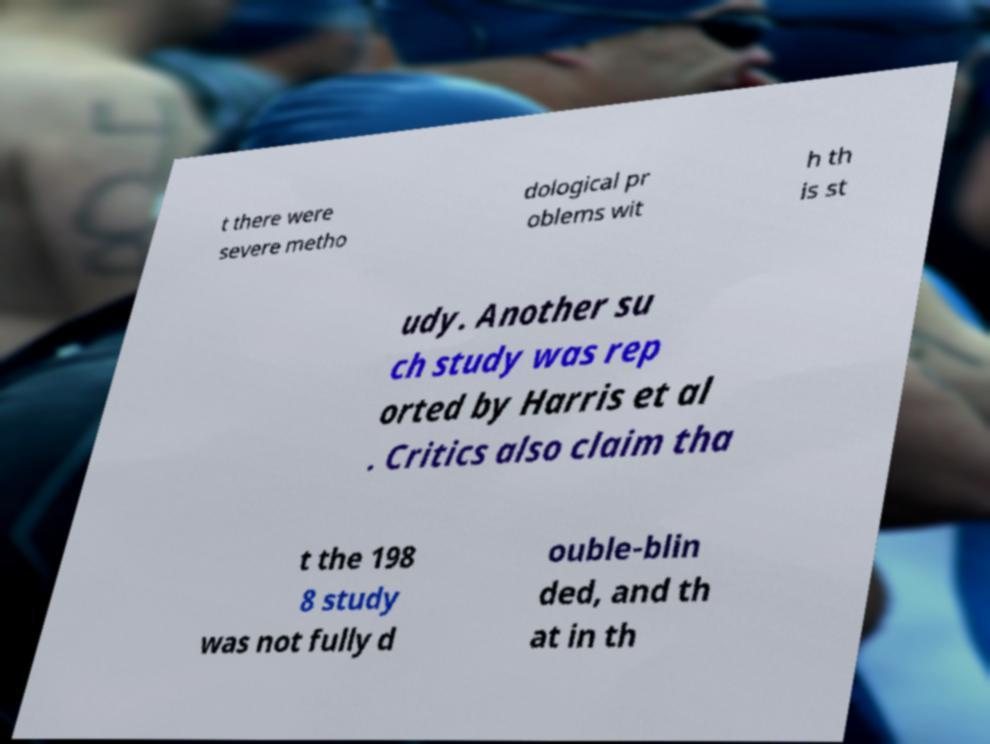I need the written content from this picture converted into text. Can you do that? t there were severe metho dological pr oblems wit h th is st udy. Another su ch study was rep orted by Harris et al . Critics also claim tha t the 198 8 study was not fully d ouble-blin ded, and th at in th 